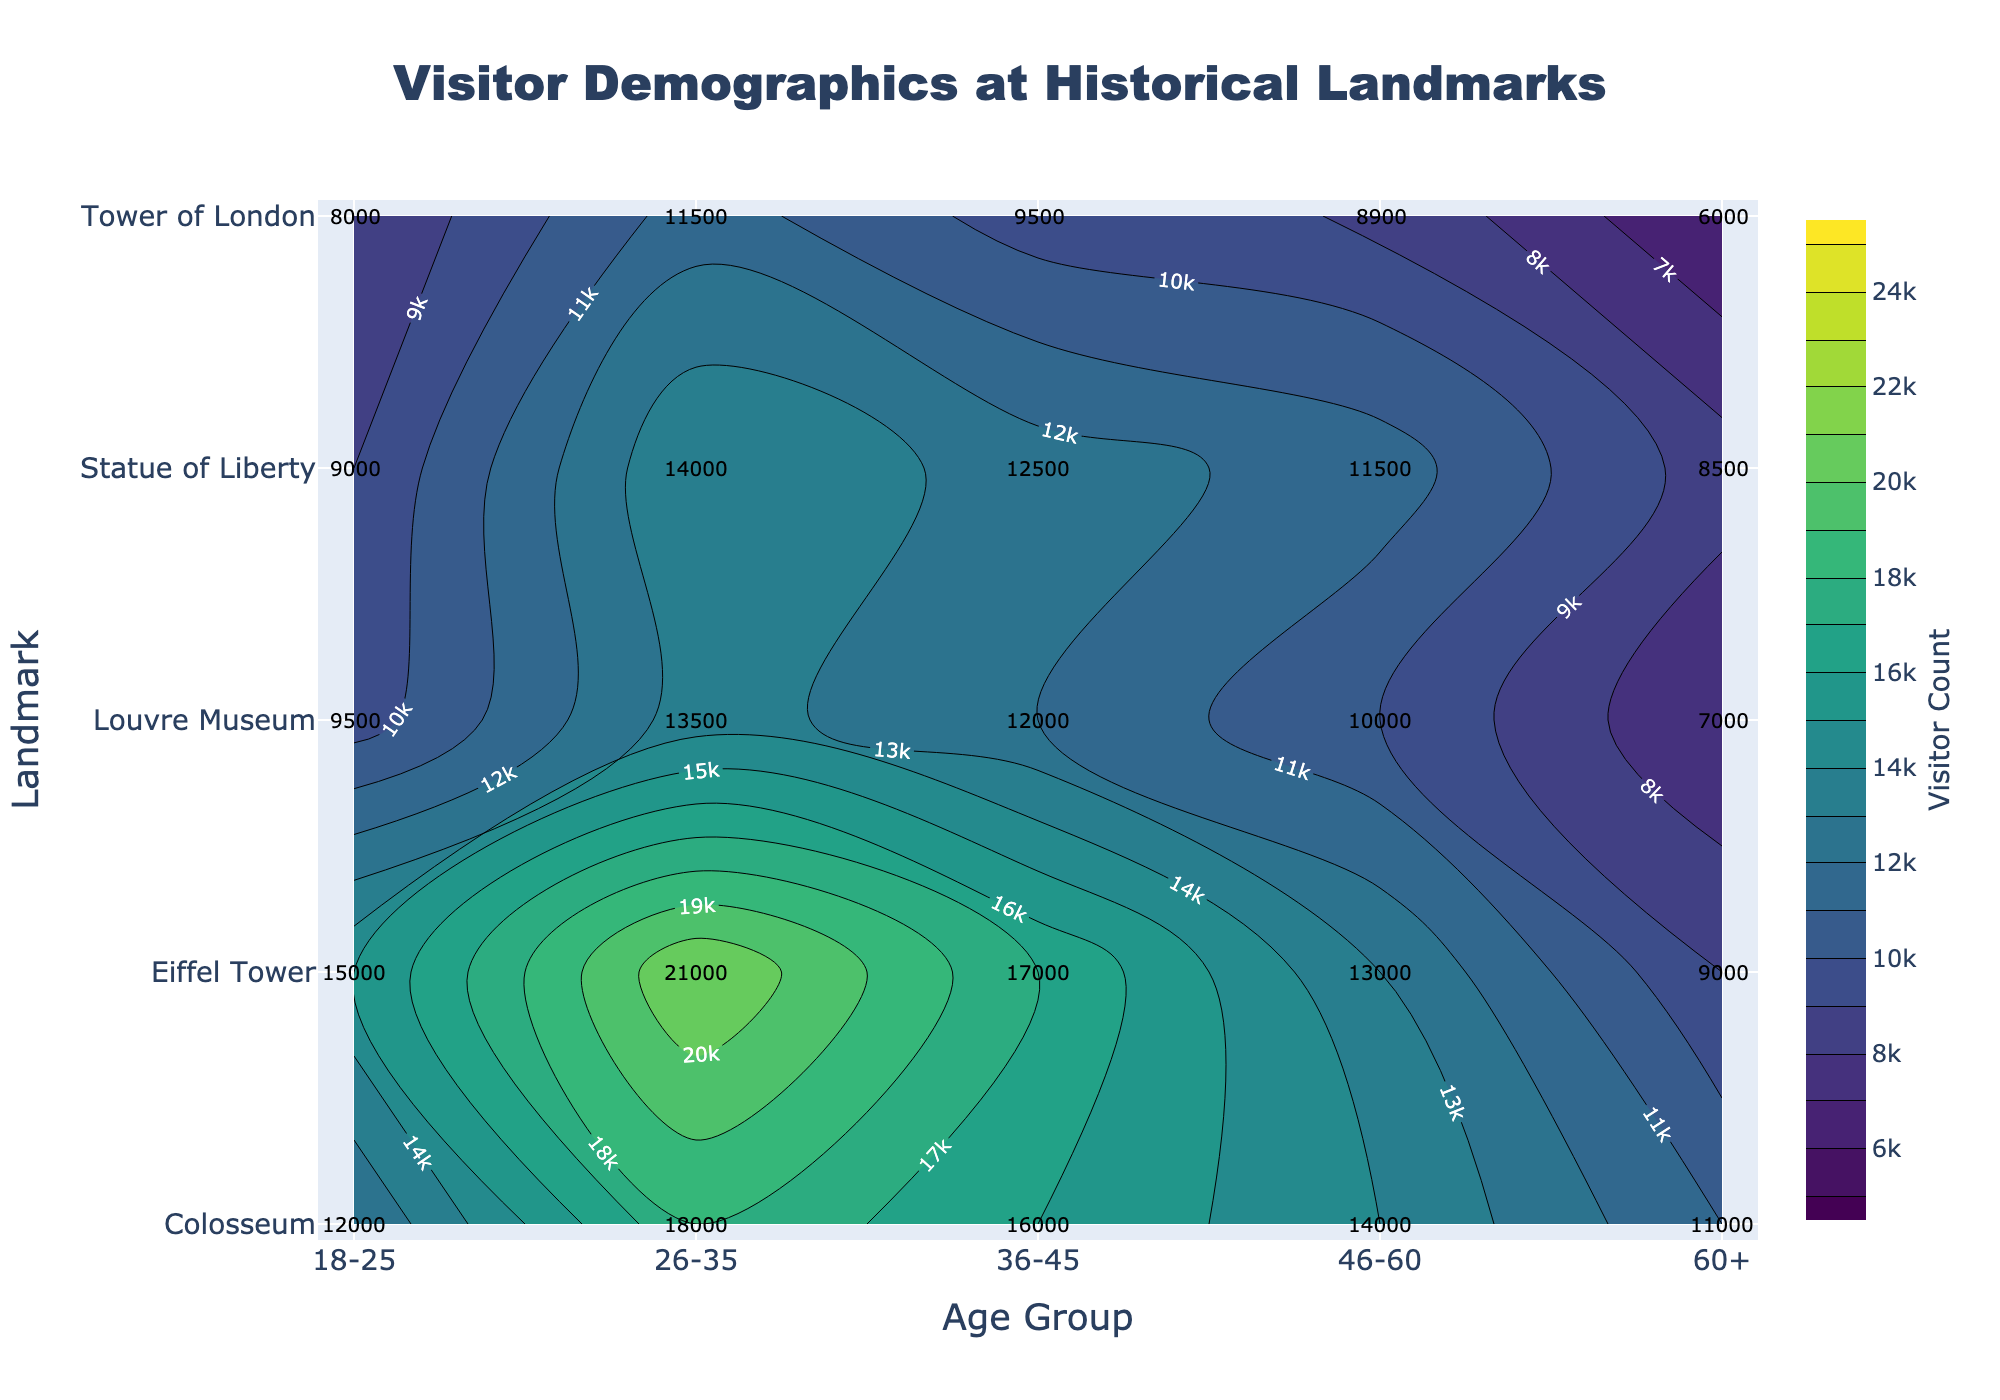How many age groups are shown on the x-axis? The x-axis of the contour plot represents different age groups. By counting the labels on the x-axis, we can see there are five age groups: 18-25, 26-35, 36-45, 46-60, and 60+.
Answer: 5 What is the title of the contour plot? The title is usually displayed prominently at the top of the plot, giving a summary of what the plot represents. In this case, it reads: "Visitor Demographics at Historical Landmarks".
Answer: Visitor Demographics at Historical Landmarks What is the visitor count for the 26-35 age group visiting the Colosseum? To find this, locate the Colosseum row and the column corresponding to the 26-35 age group. The count at the intersection is the visitor count.
Answer: 18000 Which landmark has the lowest visitor count for the 60+ age group? Look at the 60+ column and find the smallest number across all landmarks. The smallest number is 6000, which corresponds to the Tower of London.
Answer: Tower of London What is the sum of visitor counts for the 36-45 age group across all landmarks? Sum the visitor counts for the 36-45 age group across all landmarks: 17000 (Eiffel Tower) + 16000 (Colosseum) + 12000 (Louvre Museum) + 9500 (Tower of London) + 12500 (Statue of Liberty) = 67000.
Answer: 67000 Which age group has the highest visitor count for the Eiffel Tower? Examine the visitor counts for each age group under the Eiffel Tower row. The highest number is 21000, which corresponds to the 26-35 age group.
Answer: 26-35 Between the Statue of Liberty and Louvre Museum, which landmark has a higher visitor count for the 18-25 age group? Compare the visitor counts for the 18-25 age group between the Statue of Liberty (9000) and Louvre Museum (9500). The Louvre Museum has a higher count.
Answer: Louvre Museum What is the average visitor count for the Tower of London across all age groups? Sum the visitor counts for the Tower of London across age groups: 8000 + 11500 + 9500 + 8900 + 6000 = 43900. Then, divide by the number of age groups (5): 43900 / 5 = 8780.
Answer: 8780 For the 46-60 age group, which landmark has the second-highest visitor count? Sort the visitor counts for the 46-60 age group: 13000 (Eiffel Tower), 14000 (Colosseum), 10000 (Louvre Museum), 8900 (Tower of London), and 11500 (Statue of Liberty). The second-highest count is 13000, corresponding to the Eiffel Tower.
Answer: Eiffel Tower What is the difference in visitor count for the 36-45 age group between the Eiffel Tower and the Tower of London? Subtract the visitor count of the 36-45 age group for the Tower of London (9500) from that for the Eiffel Tower (17000): 17000 - 9500 = 7500.
Answer: 7500 